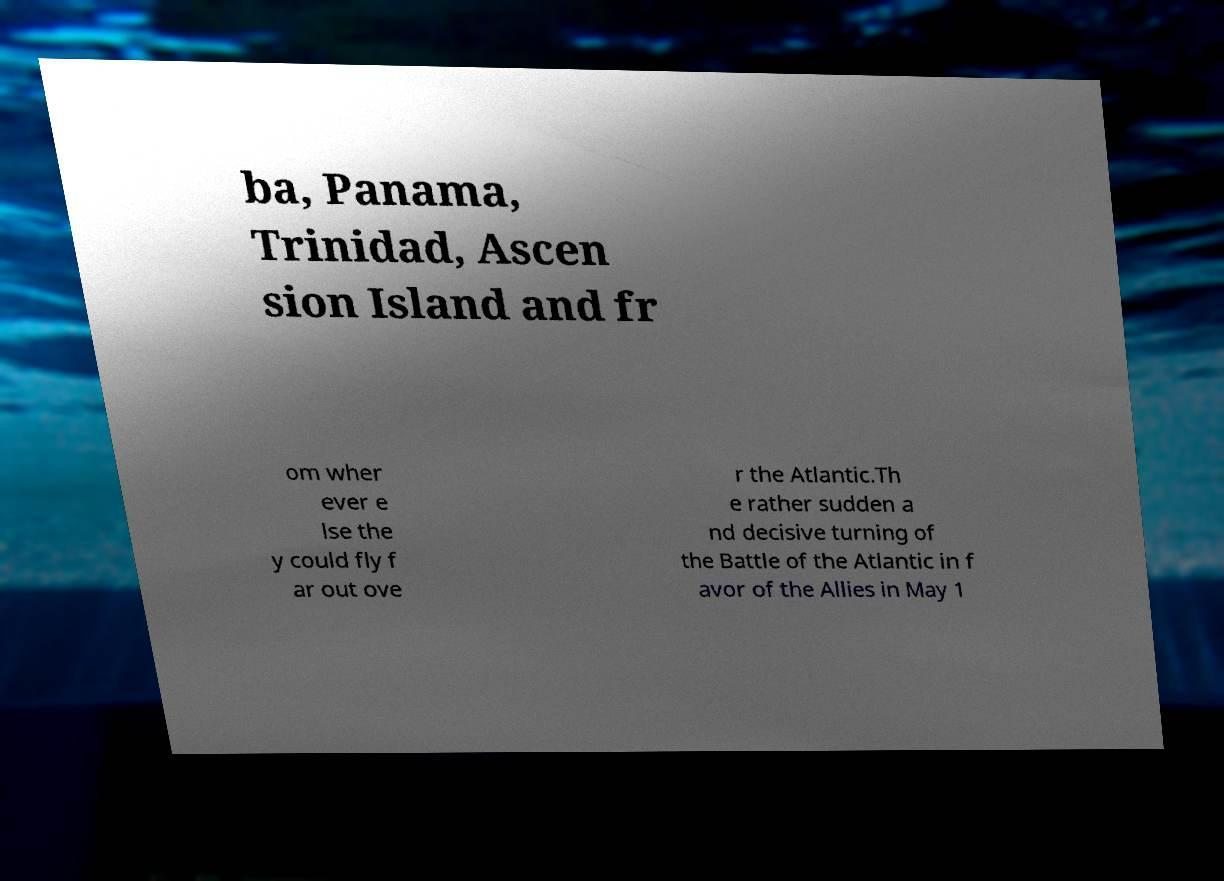Could you assist in decoding the text presented in this image and type it out clearly? ba, Panama, Trinidad, Ascen sion Island and fr om wher ever e lse the y could fly f ar out ove r the Atlantic.Th e rather sudden a nd decisive turning of the Battle of the Atlantic in f avor of the Allies in May 1 